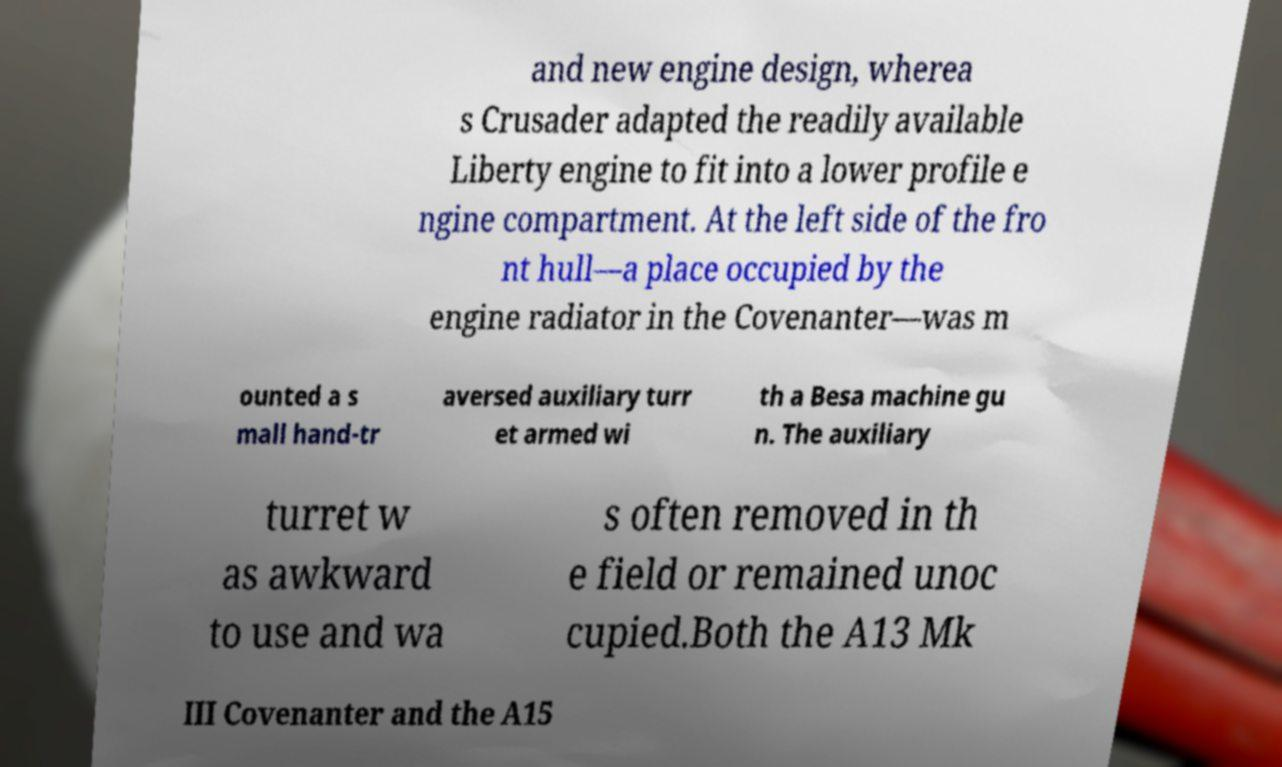Please read and relay the text visible in this image. What does it say? and new engine design, wherea s Crusader adapted the readily available Liberty engine to fit into a lower profile e ngine compartment. At the left side of the fro nt hull—a place occupied by the engine radiator in the Covenanter—was m ounted a s mall hand-tr aversed auxiliary turr et armed wi th a Besa machine gu n. The auxiliary turret w as awkward to use and wa s often removed in th e field or remained unoc cupied.Both the A13 Mk III Covenanter and the A15 